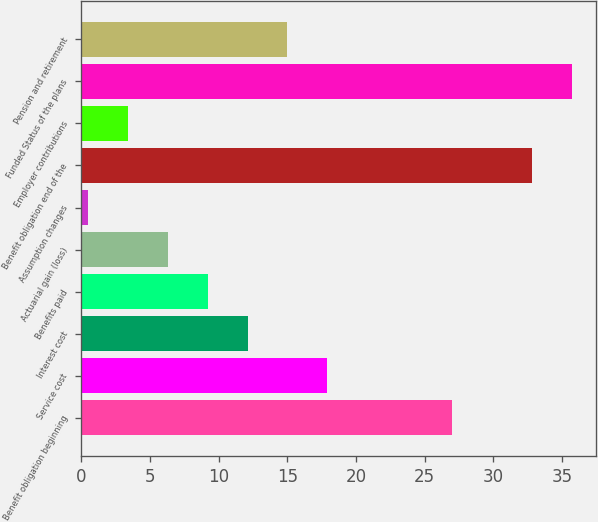Convert chart to OTSL. <chart><loc_0><loc_0><loc_500><loc_500><bar_chart><fcel>Benefit obligation beginning<fcel>Service cost<fcel>Interest cost<fcel>Benefits paid<fcel>Actuarial gain (loss)<fcel>Assumption changes<fcel>Benefit obligation end of the<fcel>Employer contributions<fcel>Funded Status of the plans<fcel>Pension and retirement<nl><fcel>27<fcel>17.9<fcel>12.1<fcel>9.2<fcel>6.3<fcel>0.5<fcel>32.8<fcel>3.4<fcel>35.7<fcel>15<nl></chart> 